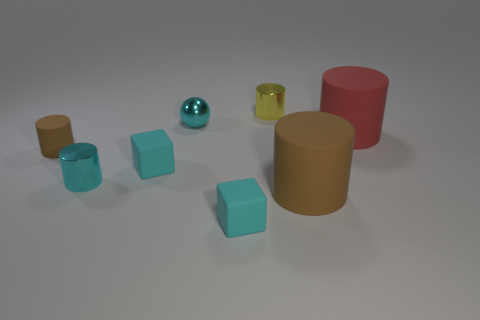What is the material of the small cylinder that is the same color as the tiny metal ball?
Give a very brief answer. Metal. Is there any other thing that is the same shape as the small brown rubber object?
Provide a short and direct response. Yes. How big is the metal cylinder that is in front of the red matte thing in front of the cyan sphere?
Ensure brevity in your answer.  Small. How many small objects are either rubber cylinders or red cylinders?
Provide a succinct answer. 1. Is the number of cyan things less than the number of yellow metallic objects?
Your answer should be very brief. No. Is there any other thing that has the same size as the red object?
Ensure brevity in your answer.  Yes. Does the tiny ball have the same color as the small rubber cylinder?
Make the answer very short. No. Is the number of small brown shiny cylinders greater than the number of red cylinders?
Keep it short and to the point. No. How many other objects are there of the same color as the small matte cylinder?
Your response must be concise. 1. How many small cyan blocks are on the left side of the brown cylinder behind the big brown thing?
Provide a succinct answer. 0. 